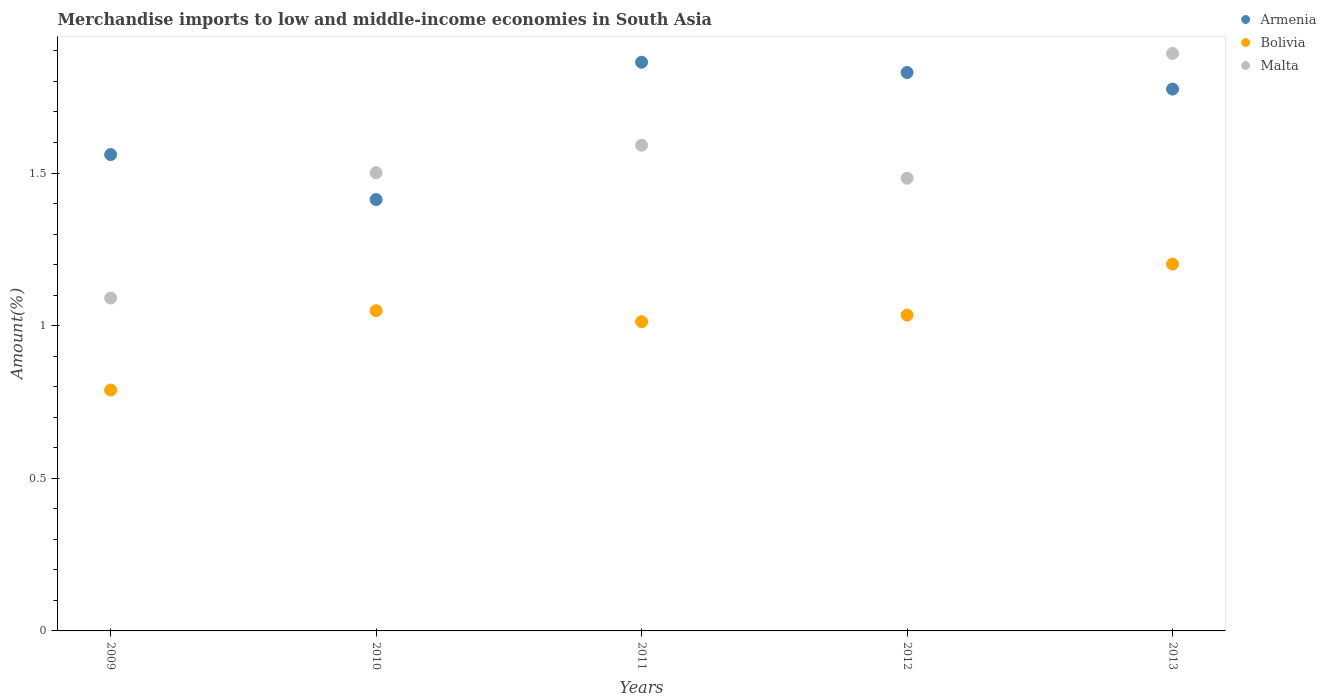What is the percentage of amount earned from merchandise imports in Bolivia in 2009?
Your answer should be compact. 0.79. Across all years, what is the maximum percentage of amount earned from merchandise imports in Malta?
Give a very brief answer. 1.89. Across all years, what is the minimum percentage of amount earned from merchandise imports in Armenia?
Your answer should be very brief. 1.41. What is the total percentage of amount earned from merchandise imports in Armenia in the graph?
Ensure brevity in your answer.  8.44. What is the difference between the percentage of amount earned from merchandise imports in Armenia in 2012 and that in 2013?
Give a very brief answer. 0.05. What is the difference between the percentage of amount earned from merchandise imports in Armenia in 2011 and the percentage of amount earned from merchandise imports in Bolivia in 2013?
Give a very brief answer. 0.66. What is the average percentage of amount earned from merchandise imports in Malta per year?
Provide a succinct answer. 1.51. In the year 2013, what is the difference between the percentage of amount earned from merchandise imports in Bolivia and percentage of amount earned from merchandise imports in Armenia?
Your answer should be compact. -0.57. In how many years, is the percentage of amount earned from merchandise imports in Armenia greater than 1.7 %?
Your answer should be very brief. 3. What is the ratio of the percentage of amount earned from merchandise imports in Malta in 2011 to that in 2013?
Give a very brief answer. 0.84. Is the percentage of amount earned from merchandise imports in Bolivia in 2009 less than that in 2010?
Your answer should be compact. Yes. What is the difference between the highest and the second highest percentage of amount earned from merchandise imports in Bolivia?
Your answer should be very brief. 0.15. What is the difference between the highest and the lowest percentage of amount earned from merchandise imports in Malta?
Offer a very short reply. 0.8. Does the percentage of amount earned from merchandise imports in Armenia monotonically increase over the years?
Keep it short and to the point. No. Is the percentage of amount earned from merchandise imports in Malta strictly greater than the percentage of amount earned from merchandise imports in Bolivia over the years?
Provide a short and direct response. Yes. Is the percentage of amount earned from merchandise imports in Armenia strictly less than the percentage of amount earned from merchandise imports in Malta over the years?
Your answer should be very brief. No. How many dotlines are there?
Provide a short and direct response. 3. How many years are there in the graph?
Your answer should be compact. 5. What is the difference between two consecutive major ticks on the Y-axis?
Make the answer very short. 0.5. Does the graph contain any zero values?
Offer a very short reply. No. Does the graph contain grids?
Give a very brief answer. No. Where does the legend appear in the graph?
Ensure brevity in your answer.  Top right. How many legend labels are there?
Your response must be concise. 3. How are the legend labels stacked?
Your response must be concise. Vertical. What is the title of the graph?
Your response must be concise. Merchandise imports to low and middle-income economies in South Asia. Does "Sint Maarten (Dutch part)" appear as one of the legend labels in the graph?
Provide a short and direct response. No. What is the label or title of the X-axis?
Your answer should be very brief. Years. What is the label or title of the Y-axis?
Ensure brevity in your answer.  Amount(%). What is the Amount(%) in Armenia in 2009?
Offer a very short reply. 1.56. What is the Amount(%) of Bolivia in 2009?
Make the answer very short. 0.79. What is the Amount(%) in Malta in 2009?
Offer a terse response. 1.09. What is the Amount(%) of Armenia in 2010?
Offer a terse response. 1.41. What is the Amount(%) in Bolivia in 2010?
Give a very brief answer. 1.05. What is the Amount(%) of Malta in 2010?
Ensure brevity in your answer.  1.5. What is the Amount(%) in Armenia in 2011?
Make the answer very short. 1.86. What is the Amount(%) of Bolivia in 2011?
Provide a succinct answer. 1.01. What is the Amount(%) in Malta in 2011?
Your answer should be compact. 1.59. What is the Amount(%) of Armenia in 2012?
Offer a very short reply. 1.83. What is the Amount(%) of Bolivia in 2012?
Offer a terse response. 1.03. What is the Amount(%) of Malta in 2012?
Offer a very short reply. 1.48. What is the Amount(%) in Armenia in 2013?
Your answer should be very brief. 1.77. What is the Amount(%) in Bolivia in 2013?
Your answer should be very brief. 1.2. What is the Amount(%) of Malta in 2013?
Make the answer very short. 1.89. Across all years, what is the maximum Amount(%) in Armenia?
Make the answer very short. 1.86. Across all years, what is the maximum Amount(%) in Bolivia?
Provide a succinct answer. 1.2. Across all years, what is the maximum Amount(%) in Malta?
Your answer should be compact. 1.89. Across all years, what is the minimum Amount(%) in Armenia?
Give a very brief answer. 1.41. Across all years, what is the minimum Amount(%) of Bolivia?
Provide a short and direct response. 0.79. Across all years, what is the minimum Amount(%) of Malta?
Offer a very short reply. 1.09. What is the total Amount(%) in Armenia in the graph?
Provide a short and direct response. 8.44. What is the total Amount(%) in Bolivia in the graph?
Your answer should be compact. 5.09. What is the total Amount(%) of Malta in the graph?
Ensure brevity in your answer.  7.56. What is the difference between the Amount(%) in Armenia in 2009 and that in 2010?
Offer a very short reply. 0.15. What is the difference between the Amount(%) in Bolivia in 2009 and that in 2010?
Offer a terse response. -0.26. What is the difference between the Amount(%) of Malta in 2009 and that in 2010?
Give a very brief answer. -0.41. What is the difference between the Amount(%) of Armenia in 2009 and that in 2011?
Offer a terse response. -0.3. What is the difference between the Amount(%) of Bolivia in 2009 and that in 2011?
Ensure brevity in your answer.  -0.22. What is the difference between the Amount(%) of Malta in 2009 and that in 2011?
Offer a terse response. -0.5. What is the difference between the Amount(%) of Armenia in 2009 and that in 2012?
Ensure brevity in your answer.  -0.27. What is the difference between the Amount(%) in Bolivia in 2009 and that in 2012?
Ensure brevity in your answer.  -0.25. What is the difference between the Amount(%) of Malta in 2009 and that in 2012?
Provide a succinct answer. -0.39. What is the difference between the Amount(%) in Armenia in 2009 and that in 2013?
Give a very brief answer. -0.21. What is the difference between the Amount(%) in Bolivia in 2009 and that in 2013?
Give a very brief answer. -0.41. What is the difference between the Amount(%) in Malta in 2009 and that in 2013?
Your answer should be compact. -0.8. What is the difference between the Amount(%) in Armenia in 2010 and that in 2011?
Your answer should be compact. -0.45. What is the difference between the Amount(%) in Bolivia in 2010 and that in 2011?
Your answer should be compact. 0.04. What is the difference between the Amount(%) in Malta in 2010 and that in 2011?
Offer a terse response. -0.09. What is the difference between the Amount(%) of Armenia in 2010 and that in 2012?
Give a very brief answer. -0.42. What is the difference between the Amount(%) in Bolivia in 2010 and that in 2012?
Your answer should be very brief. 0.01. What is the difference between the Amount(%) of Malta in 2010 and that in 2012?
Provide a succinct answer. 0.02. What is the difference between the Amount(%) of Armenia in 2010 and that in 2013?
Offer a very short reply. -0.36. What is the difference between the Amount(%) in Bolivia in 2010 and that in 2013?
Make the answer very short. -0.15. What is the difference between the Amount(%) of Malta in 2010 and that in 2013?
Your answer should be compact. -0.39. What is the difference between the Amount(%) of Armenia in 2011 and that in 2012?
Provide a succinct answer. 0.03. What is the difference between the Amount(%) of Bolivia in 2011 and that in 2012?
Your answer should be very brief. -0.02. What is the difference between the Amount(%) in Malta in 2011 and that in 2012?
Your answer should be compact. 0.11. What is the difference between the Amount(%) in Armenia in 2011 and that in 2013?
Provide a succinct answer. 0.09. What is the difference between the Amount(%) of Bolivia in 2011 and that in 2013?
Provide a succinct answer. -0.19. What is the difference between the Amount(%) of Malta in 2011 and that in 2013?
Your answer should be very brief. -0.3. What is the difference between the Amount(%) of Armenia in 2012 and that in 2013?
Keep it short and to the point. 0.05. What is the difference between the Amount(%) in Bolivia in 2012 and that in 2013?
Your response must be concise. -0.17. What is the difference between the Amount(%) in Malta in 2012 and that in 2013?
Ensure brevity in your answer.  -0.41. What is the difference between the Amount(%) of Armenia in 2009 and the Amount(%) of Bolivia in 2010?
Your answer should be very brief. 0.51. What is the difference between the Amount(%) of Armenia in 2009 and the Amount(%) of Malta in 2010?
Your answer should be very brief. 0.06. What is the difference between the Amount(%) in Bolivia in 2009 and the Amount(%) in Malta in 2010?
Offer a terse response. -0.71. What is the difference between the Amount(%) in Armenia in 2009 and the Amount(%) in Bolivia in 2011?
Offer a terse response. 0.55. What is the difference between the Amount(%) of Armenia in 2009 and the Amount(%) of Malta in 2011?
Ensure brevity in your answer.  -0.03. What is the difference between the Amount(%) of Bolivia in 2009 and the Amount(%) of Malta in 2011?
Give a very brief answer. -0.8. What is the difference between the Amount(%) in Armenia in 2009 and the Amount(%) in Bolivia in 2012?
Offer a terse response. 0.53. What is the difference between the Amount(%) in Armenia in 2009 and the Amount(%) in Malta in 2012?
Provide a succinct answer. 0.08. What is the difference between the Amount(%) of Bolivia in 2009 and the Amount(%) of Malta in 2012?
Provide a short and direct response. -0.69. What is the difference between the Amount(%) in Armenia in 2009 and the Amount(%) in Bolivia in 2013?
Your answer should be compact. 0.36. What is the difference between the Amount(%) in Armenia in 2009 and the Amount(%) in Malta in 2013?
Give a very brief answer. -0.33. What is the difference between the Amount(%) in Bolivia in 2009 and the Amount(%) in Malta in 2013?
Provide a succinct answer. -1.1. What is the difference between the Amount(%) in Armenia in 2010 and the Amount(%) in Bolivia in 2011?
Give a very brief answer. 0.4. What is the difference between the Amount(%) of Armenia in 2010 and the Amount(%) of Malta in 2011?
Give a very brief answer. -0.18. What is the difference between the Amount(%) of Bolivia in 2010 and the Amount(%) of Malta in 2011?
Offer a very short reply. -0.54. What is the difference between the Amount(%) in Armenia in 2010 and the Amount(%) in Bolivia in 2012?
Make the answer very short. 0.38. What is the difference between the Amount(%) in Armenia in 2010 and the Amount(%) in Malta in 2012?
Ensure brevity in your answer.  -0.07. What is the difference between the Amount(%) in Bolivia in 2010 and the Amount(%) in Malta in 2012?
Provide a short and direct response. -0.43. What is the difference between the Amount(%) of Armenia in 2010 and the Amount(%) of Bolivia in 2013?
Give a very brief answer. 0.21. What is the difference between the Amount(%) in Armenia in 2010 and the Amount(%) in Malta in 2013?
Provide a succinct answer. -0.48. What is the difference between the Amount(%) in Bolivia in 2010 and the Amount(%) in Malta in 2013?
Offer a very short reply. -0.84. What is the difference between the Amount(%) in Armenia in 2011 and the Amount(%) in Bolivia in 2012?
Keep it short and to the point. 0.83. What is the difference between the Amount(%) of Armenia in 2011 and the Amount(%) of Malta in 2012?
Make the answer very short. 0.38. What is the difference between the Amount(%) in Bolivia in 2011 and the Amount(%) in Malta in 2012?
Ensure brevity in your answer.  -0.47. What is the difference between the Amount(%) of Armenia in 2011 and the Amount(%) of Bolivia in 2013?
Make the answer very short. 0.66. What is the difference between the Amount(%) in Armenia in 2011 and the Amount(%) in Malta in 2013?
Ensure brevity in your answer.  -0.03. What is the difference between the Amount(%) in Bolivia in 2011 and the Amount(%) in Malta in 2013?
Ensure brevity in your answer.  -0.88. What is the difference between the Amount(%) in Armenia in 2012 and the Amount(%) in Bolivia in 2013?
Your answer should be very brief. 0.63. What is the difference between the Amount(%) in Armenia in 2012 and the Amount(%) in Malta in 2013?
Make the answer very short. -0.06. What is the difference between the Amount(%) of Bolivia in 2012 and the Amount(%) of Malta in 2013?
Provide a short and direct response. -0.86. What is the average Amount(%) of Armenia per year?
Offer a terse response. 1.69. What is the average Amount(%) of Bolivia per year?
Your response must be concise. 1.02. What is the average Amount(%) of Malta per year?
Offer a terse response. 1.51. In the year 2009, what is the difference between the Amount(%) in Armenia and Amount(%) in Bolivia?
Offer a very short reply. 0.77. In the year 2009, what is the difference between the Amount(%) in Armenia and Amount(%) in Malta?
Make the answer very short. 0.47. In the year 2009, what is the difference between the Amount(%) in Bolivia and Amount(%) in Malta?
Your response must be concise. -0.3. In the year 2010, what is the difference between the Amount(%) in Armenia and Amount(%) in Bolivia?
Your response must be concise. 0.36. In the year 2010, what is the difference between the Amount(%) in Armenia and Amount(%) in Malta?
Make the answer very short. -0.09. In the year 2010, what is the difference between the Amount(%) of Bolivia and Amount(%) of Malta?
Ensure brevity in your answer.  -0.45. In the year 2011, what is the difference between the Amount(%) in Armenia and Amount(%) in Bolivia?
Make the answer very short. 0.85. In the year 2011, what is the difference between the Amount(%) of Armenia and Amount(%) of Malta?
Offer a very short reply. 0.27. In the year 2011, what is the difference between the Amount(%) of Bolivia and Amount(%) of Malta?
Keep it short and to the point. -0.58. In the year 2012, what is the difference between the Amount(%) in Armenia and Amount(%) in Bolivia?
Ensure brevity in your answer.  0.79. In the year 2012, what is the difference between the Amount(%) in Armenia and Amount(%) in Malta?
Offer a terse response. 0.35. In the year 2012, what is the difference between the Amount(%) of Bolivia and Amount(%) of Malta?
Your response must be concise. -0.45. In the year 2013, what is the difference between the Amount(%) of Armenia and Amount(%) of Bolivia?
Your response must be concise. 0.57. In the year 2013, what is the difference between the Amount(%) in Armenia and Amount(%) in Malta?
Your answer should be compact. -0.12. In the year 2013, what is the difference between the Amount(%) of Bolivia and Amount(%) of Malta?
Ensure brevity in your answer.  -0.69. What is the ratio of the Amount(%) in Armenia in 2009 to that in 2010?
Keep it short and to the point. 1.1. What is the ratio of the Amount(%) in Bolivia in 2009 to that in 2010?
Offer a terse response. 0.75. What is the ratio of the Amount(%) in Malta in 2009 to that in 2010?
Keep it short and to the point. 0.73. What is the ratio of the Amount(%) of Armenia in 2009 to that in 2011?
Provide a short and direct response. 0.84. What is the ratio of the Amount(%) in Bolivia in 2009 to that in 2011?
Keep it short and to the point. 0.78. What is the ratio of the Amount(%) of Malta in 2009 to that in 2011?
Your answer should be compact. 0.69. What is the ratio of the Amount(%) in Armenia in 2009 to that in 2012?
Ensure brevity in your answer.  0.85. What is the ratio of the Amount(%) in Bolivia in 2009 to that in 2012?
Give a very brief answer. 0.76. What is the ratio of the Amount(%) in Malta in 2009 to that in 2012?
Provide a succinct answer. 0.74. What is the ratio of the Amount(%) in Armenia in 2009 to that in 2013?
Keep it short and to the point. 0.88. What is the ratio of the Amount(%) of Bolivia in 2009 to that in 2013?
Ensure brevity in your answer.  0.66. What is the ratio of the Amount(%) in Malta in 2009 to that in 2013?
Keep it short and to the point. 0.58. What is the ratio of the Amount(%) of Armenia in 2010 to that in 2011?
Ensure brevity in your answer.  0.76. What is the ratio of the Amount(%) of Bolivia in 2010 to that in 2011?
Give a very brief answer. 1.04. What is the ratio of the Amount(%) of Malta in 2010 to that in 2011?
Your response must be concise. 0.94. What is the ratio of the Amount(%) of Armenia in 2010 to that in 2012?
Your response must be concise. 0.77. What is the ratio of the Amount(%) of Bolivia in 2010 to that in 2012?
Your answer should be very brief. 1.01. What is the ratio of the Amount(%) of Malta in 2010 to that in 2012?
Your answer should be compact. 1.01. What is the ratio of the Amount(%) in Armenia in 2010 to that in 2013?
Your response must be concise. 0.8. What is the ratio of the Amount(%) of Bolivia in 2010 to that in 2013?
Your answer should be very brief. 0.87. What is the ratio of the Amount(%) in Malta in 2010 to that in 2013?
Your response must be concise. 0.79. What is the ratio of the Amount(%) in Armenia in 2011 to that in 2012?
Ensure brevity in your answer.  1.02. What is the ratio of the Amount(%) in Bolivia in 2011 to that in 2012?
Offer a terse response. 0.98. What is the ratio of the Amount(%) in Malta in 2011 to that in 2012?
Provide a succinct answer. 1.07. What is the ratio of the Amount(%) of Armenia in 2011 to that in 2013?
Your answer should be very brief. 1.05. What is the ratio of the Amount(%) in Bolivia in 2011 to that in 2013?
Offer a terse response. 0.84. What is the ratio of the Amount(%) in Malta in 2011 to that in 2013?
Give a very brief answer. 0.84. What is the ratio of the Amount(%) of Armenia in 2012 to that in 2013?
Your answer should be very brief. 1.03. What is the ratio of the Amount(%) of Bolivia in 2012 to that in 2013?
Your answer should be compact. 0.86. What is the ratio of the Amount(%) of Malta in 2012 to that in 2013?
Ensure brevity in your answer.  0.78. What is the difference between the highest and the second highest Amount(%) in Armenia?
Offer a very short reply. 0.03. What is the difference between the highest and the second highest Amount(%) of Bolivia?
Your answer should be compact. 0.15. What is the difference between the highest and the second highest Amount(%) of Malta?
Offer a terse response. 0.3. What is the difference between the highest and the lowest Amount(%) of Armenia?
Make the answer very short. 0.45. What is the difference between the highest and the lowest Amount(%) of Bolivia?
Make the answer very short. 0.41. What is the difference between the highest and the lowest Amount(%) in Malta?
Your response must be concise. 0.8. 